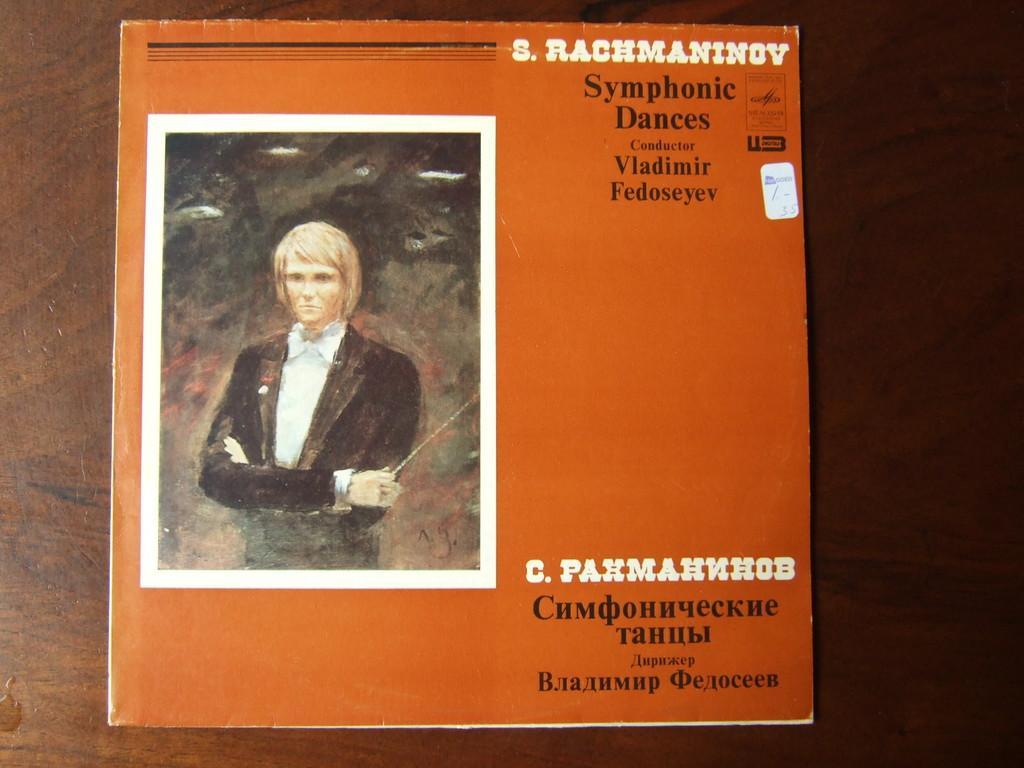How would you summarize this image in a sentence or two? In this image, we can see a table, on that table, we can see a book. On the left side of the book, we can see a picture of a person. On the right side of the book, we can see a some text written on it. 